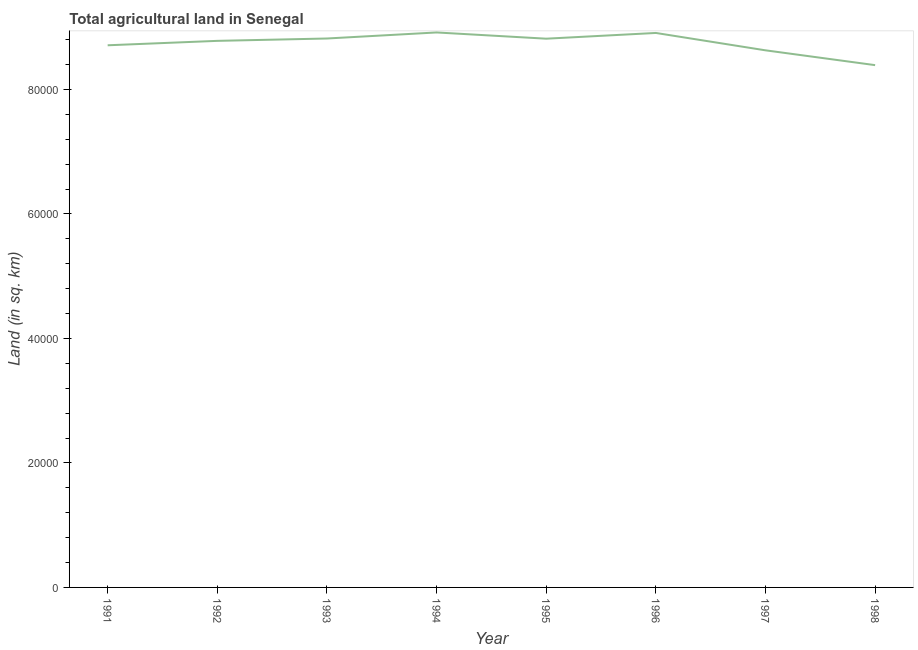What is the agricultural land in 1998?
Your answer should be compact. 8.39e+04. Across all years, what is the maximum agricultural land?
Provide a succinct answer. 8.92e+04. Across all years, what is the minimum agricultural land?
Your answer should be compact. 8.39e+04. In which year was the agricultural land minimum?
Ensure brevity in your answer.  1998. What is the sum of the agricultural land?
Your answer should be very brief. 7.00e+05. What is the difference between the agricultural land in 1991 and 1993?
Offer a very short reply. -1090. What is the average agricultural land per year?
Your answer should be compact. 8.75e+04. What is the median agricultural land?
Your response must be concise. 8.80e+04. In how many years, is the agricultural land greater than 24000 sq. km?
Make the answer very short. 8. What is the ratio of the agricultural land in 1996 to that in 1997?
Your answer should be compact. 1.03. Is the agricultural land in 1996 less than that in 1998?
Provide a succinct answer. No. What is the difference between the highest and the second highest agricultural land?
Offer a very short reply. 80. Is the sum of the agricultural land in 1994 and 1996 greater than the maximum agricultural land across all years?
Provide a succinct answer. Yes. What is the difference between the highest and the lowest agricultural land?
Provide a short and direct response. 5250. In how many years, is the agricultural land greater than the average agricultural land taken over all years?
Offer a very short reply. 5. How many lines are there?
Offer a very short reply. 1. How many years are there in the graph?
Provide a short and direct response. 8. What is the difference between two consecutive major ticks on the Y-axis?
Offer a terse response. 2.00e+04. Are the values on the major ticks of Y-axis written in scientific E-notation?
Your answer should be compact. No. Does the graph contain grids?
Ensure brevity in your answer.  No. What is the title of the graph?
Your answer should be very brief. Total agricultural land in Senegal. What is the label or title of the Y-axis?
Provide a short and direct response. Land (in sq. km). What is the Land (in sq. km) in 1991?
Provide a short and direct response. 8.71e+04. What is the Land (in sq. km) in 1992?
Keep it short and to the point. 8.78e+04. What is the Land (in sq. km) of 1993?
Give a very brief answer. 8.82e+04. What is the Land (in sq. km) in 1994?
Your answer should be very brief. 8.92e+04. What is the Land (in sq. km) of 1995?
Offer a terse response. 8.82e+04. What is the Land (in sq. km) of 1996?
Make the answer very short. 8.91e+04. What is the Land (in sq. km) in 1997?
Offer a terse response. 8.63e+04. What is the Land (in sq. km) in 1998?
Your answer should be compact. 8.39e+04. What is the difference between the Land (in sq. km) in 1991 and 1992?
Provide a succinct answer. -710. What is the difference between the Land (in sq. km) in 1991 and 1993?
Make the answer very short. -1090. What is the difference between the Land (in sq. km) in 1991 and 1994?
Your answer should be very brief. -2060. What is the difference between the Land (in sq. km) in 1991 and 1995?
Offer a very short reply. -1060. What is the difference between the Land (in sq. km) in 1991 and 1996?
Keep it short and to the point. -1980. What is the difference between the Land (in sq. km) in 1991 and 1997?
Keep it short and to the point. 810. What is the difference between the Land (in sq. km) in 1991 and 1998?
Your response must be concise. 3190. What is the difference between the Land (in sq. km) in 1992 and 1993?
Give a very brief answer. -380. What is the difference between the Land (in sq. km) in 1992 and 1994?
Your answer should be very brief. -1350. What is the difference between the Land (in sq. km) in 1992 and 1995?
Provide a short and direct response. -350. What is the difference between the Land (in sq. km) in 1992 and 1996?
Provide a succinct answer. -1270. What is the difference between the Land (in sq. km) in 1992 and 1997?
Offer a very short reply. 1520. What is the difference between the Land (in sq. km) in 1992 and 1998?
Provide a succinct answer. 3900. What is the difference between the Land (in sq. km) in 1993 and 1994?
Your answer should be compact. -970. What is the difference between the Land (in sq. km) in 1993 and 1995?
Give a very brief answer. 30. What is the difference between the Land (in sq. km) in 1993 and 1996?
Keep it short and to the point. -890. What is the difference between the Land (in sq. km) in 1993 and 1997?
Give a very brief answer. 1900. What is the difference between the Land (in sq. km) in 1993 and 1998?
Make the answer very short. 4280. What is the difference between the Land (in sq. km) in 1994 and 1995?
Provide a short and direct response. 1000. What is the difference between the Land (in sq. km) in 1994 and 1996?
Ensure brevity in your answer.  80. What is the difference between the Land (in sq. km) in 1994 and 1997?
Provide a succinct answer. 2870. What is the difference between the Land (in sq. km) in 1994 and 1998?
Your answer should be compact. 5250. What is the difference between the Land (in sq. km) in 1995 and 1996?
Provide a short and direct response. -920. What is the difference between the Land (in sq. km) in 1995 and 1997?
Provide a short and direct response. 1870. What is the difference between the Land (in sq. km) in 1995 and 1998?
Offer a very short reply. 4250. What is the difference between the Land (in sq. km) in 1996 and 1997?
Provide a succinct answer. 2790. What is the difference between the Land (in sq. km) in 1996 and 1998?
Make the answer very short. 5170. What is the difference between the Land (in sq. km) in 1997 and 1998?
Make the answer very short. 2380. What is the ratio of the Land (in sq. km) in 1991 to that in 1994?
Your answer should be very brief. 0.98. What is the ratio of the Land (in sq. km) in 1991 to that in 1996?
Give a very brief answer. 0.98. What is the ratio of the Land (in sq. km) in 1991 to that in 1998?
Keep it short and to the point. 1.04. What is the ratio of the Land (in sq. km) in 1992 to that in 1993?
Provide a succinct answer. 1. What is the ratio of the Land (in sq. km) in 1992 to that in 1994?
Your answer should be very brief. 0.98. What is the ratio of the Land (in sq. km) in 1992 to that in 1995?
Provide a succinct answer. 1. What is the ratio of the Land (in sq. km) in 1992 to that in 1997?
Offer a very short reply. 1.02. What is the ratio of the Land (in sq. km) in 1992 to that in 1998?
Keep it short and to the point. 1.05. What is the ratio of the Land (in sq. km) in 1993 to that in 1996?
Your response must be concise. 0.99. What is the ratio of the Land (in sq. km) in 1993 to that in 1997?
Your answer should be compact. 1.02. What is the ratio of the Land (in sq. km) in 1993 to that in 1998?
Your answer should be compact. 1.05. What is the ratio of the Land (in sq. km) in 1994 to that in 1996?
Offer a terse response. 1. What is the ratio of the Land (in sq. km) in 1994 to that in 1997?
Your answer should be compact. 1.03. What is the ratio of the Land (in sq. km) in 1994 to that in 1998?
Provide a succinct answer. 1.06. What is the ratio of the Land (in sq. km) in 1995 to that in 1998?
Keep it short and to the point. 1.05. What is the ratio of the Land (in sq. km) in 1996 to that in 1997?
Give a very brief answer. 1.03. What is the ratio of the Land (in sq. km) in 1996 to that in 1998?
Your answer should be very brief. 1.06. What is the ratio of the Land (in sq. km) in 1997 to that in 1998?
Your answer should be very brief. 1.03. 